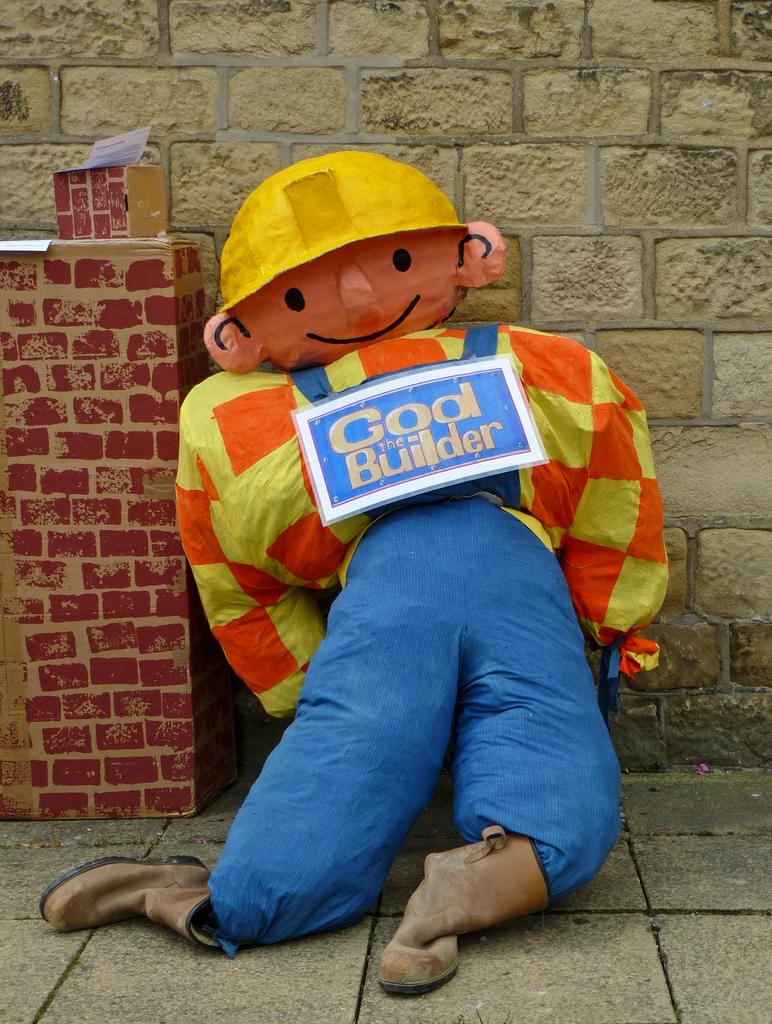What type of object can be seen in the image? There is a toy in the image. What is the toy placed on or near? There is a board in the image. What other objects are visible in the image? There are boxes in the image. What can be seen in the background of the image? There is a wall in the background of the image. What type of snake is crawling on the toy in the image? There is no snake present in the image; it only features a toy, a board, boxes, and a wall in the background. 